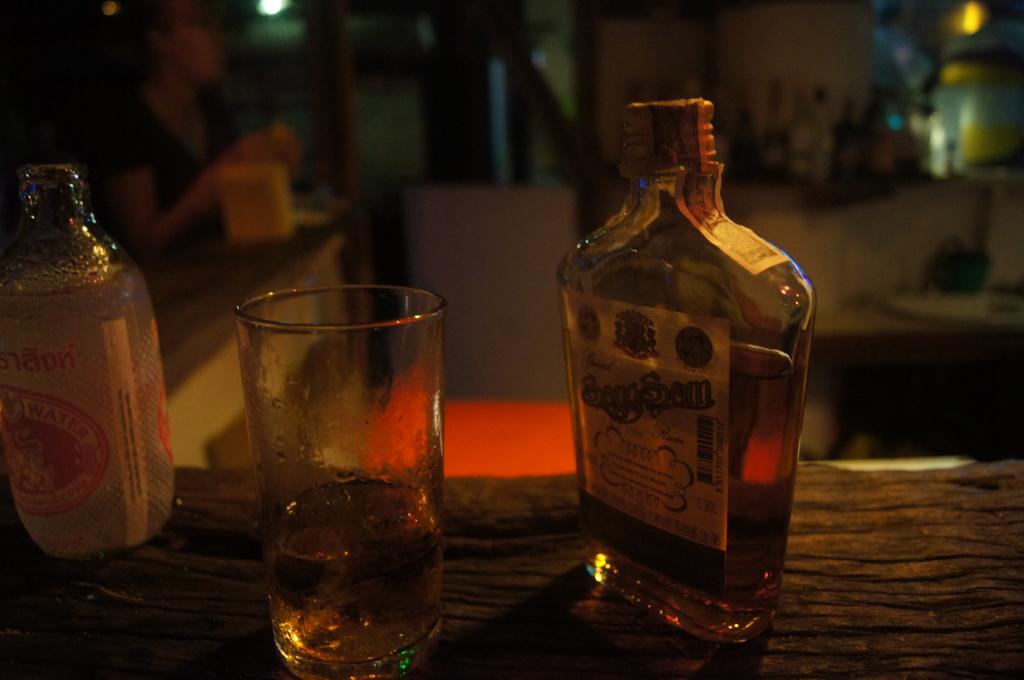What is in the bottle on the left?
Offer a terse response. Water. 